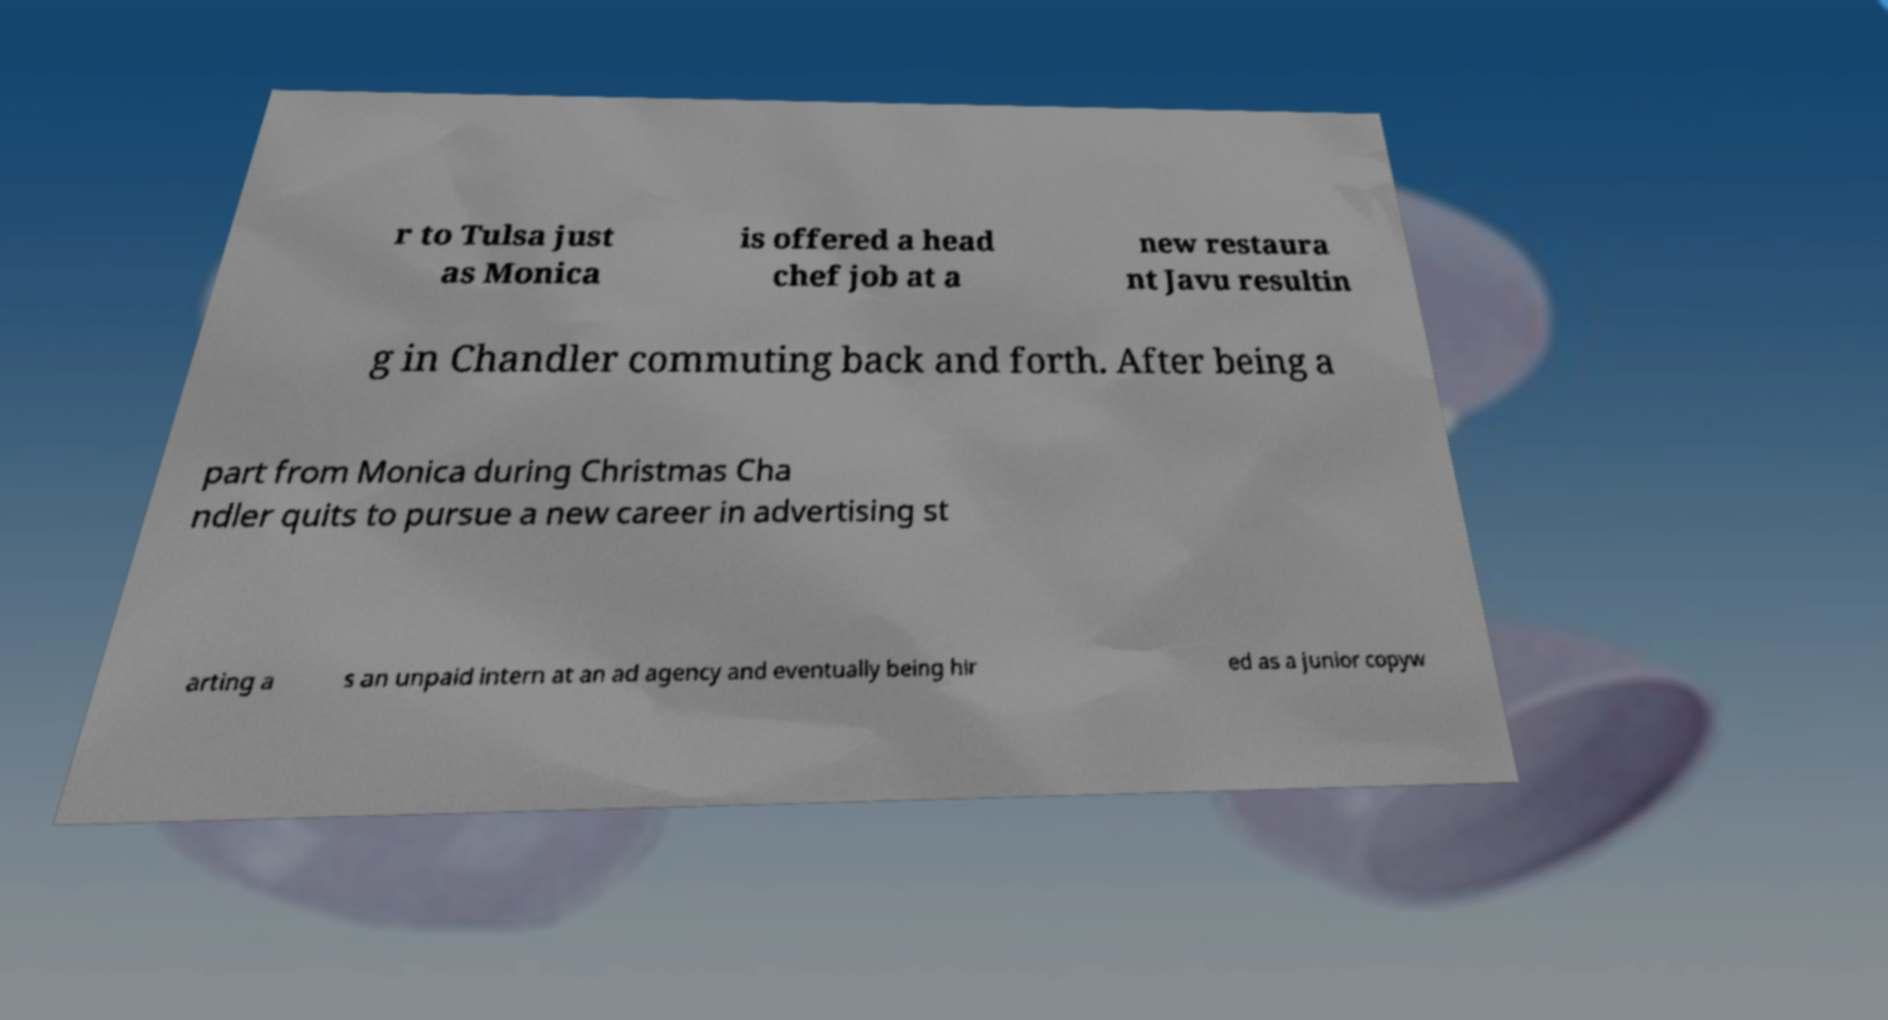Could you extract and type out the text from this image? r to Tulsa just as Monica is offered a head chef job at a new restaura nt Javu resultin g in Chandler commuting back and forth. After being a part from Monica during Christmas Cha ndler quits to pursue a new career in advertising st arting a s an unpaid intern at an ad agency and eventually being hir ed as a junior copyw 